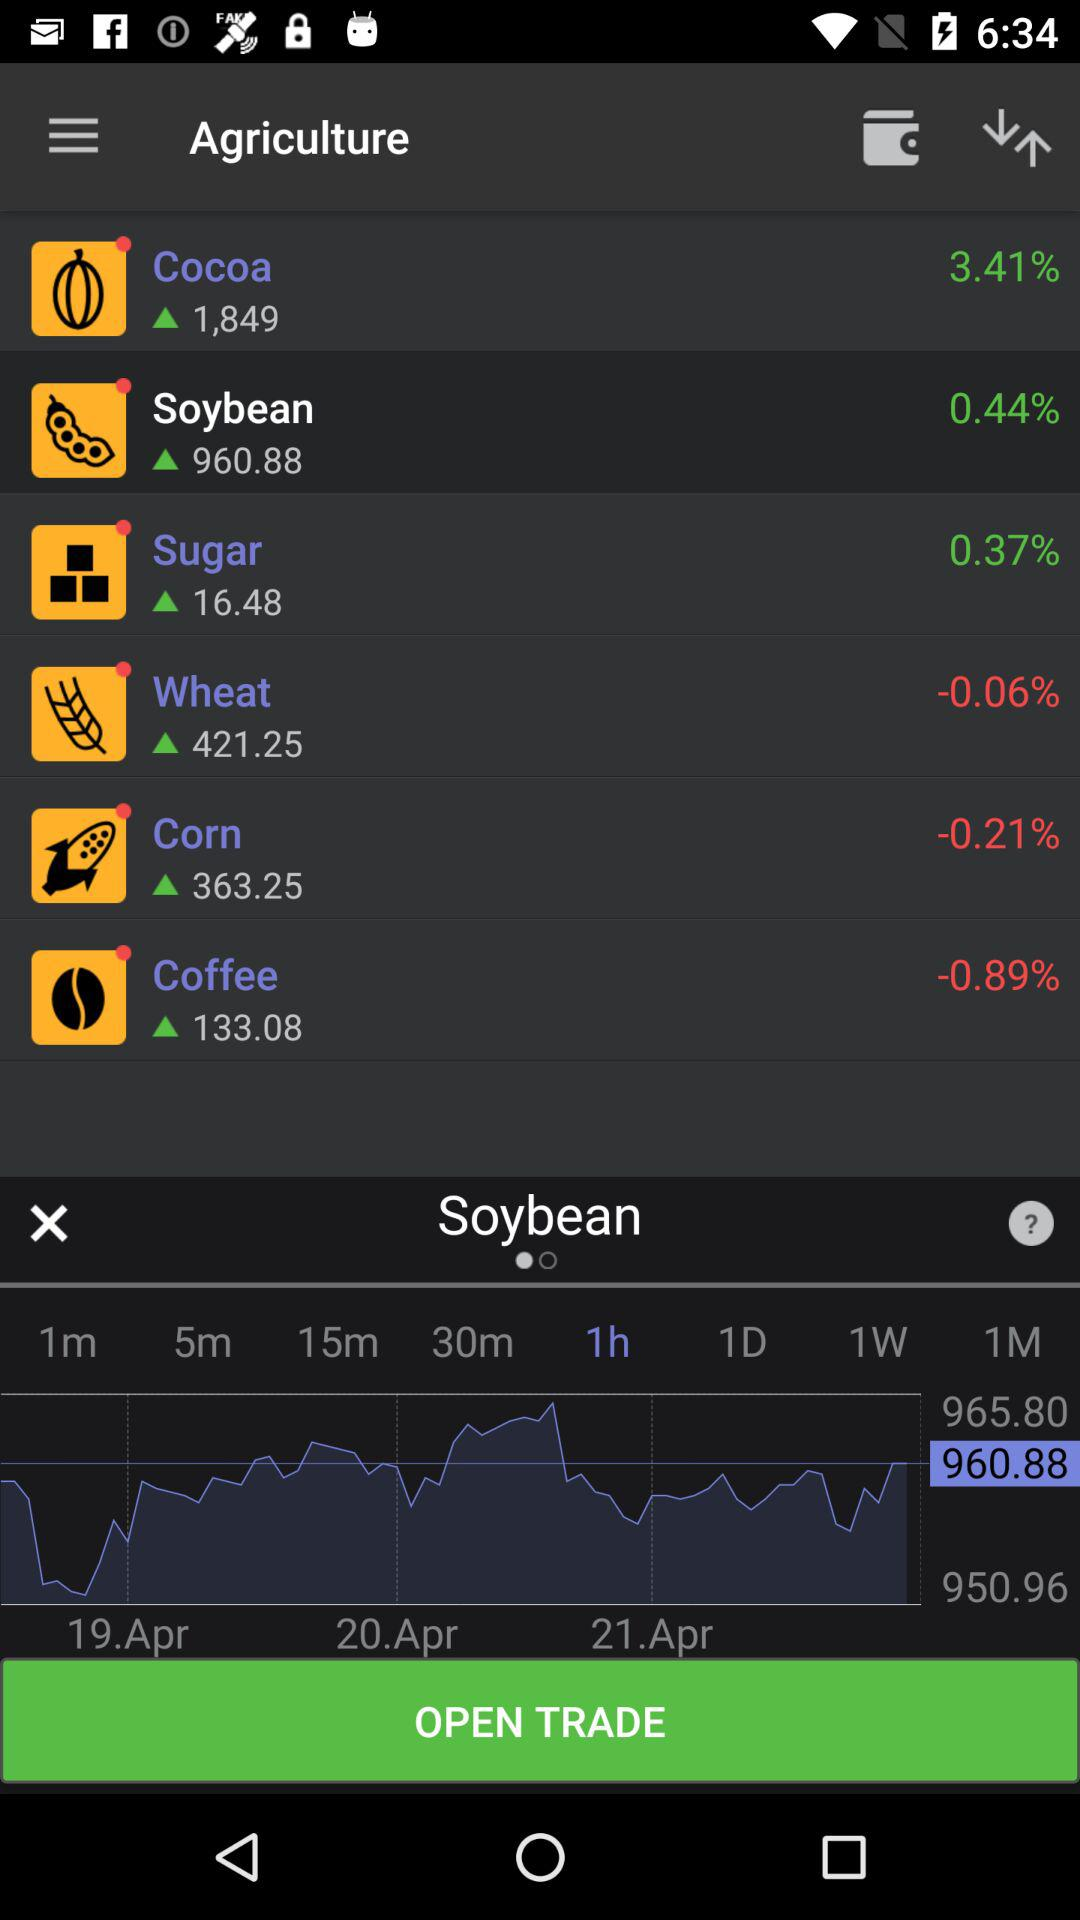What is the percentage change for "Coffee"? The percentage change for "Coffee" is -0.89. 